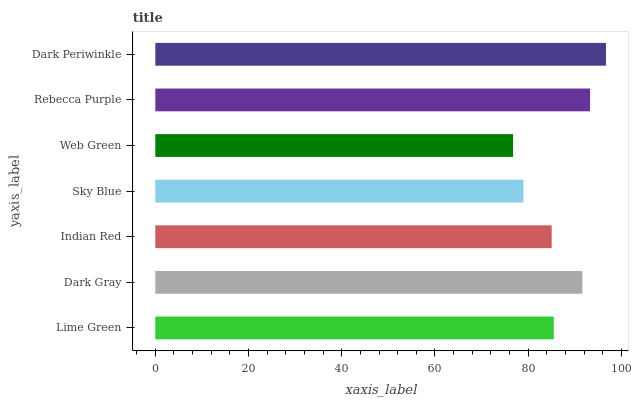Is Web Green the minimum?
Answer yes or no. Yes. Is Dark Periwinkle the maximum?
Answer yes or no. Yes. Is Dark Gray the minimum?
Answer yes or no. No. Is Dark Gray the maximum?
Answer yes or no. No. Is Dark Gray greater than Lime Green?
Answer yes or no. Yes. Is Lime Green less than Dark Gray?
Answer yes or no. Yes. Is Lime Green greater than Dark Gray?
Answer yes or no. No. Is Dark Gray less than Lime Green?
Answer yes or no. No. Is Lime Green the high median?
Answer yes or no. Yes. Is Lime Green the low median?
Answer yes or no. Yes. Is Dark Periwinkle the high median?
Answer yes or no. No. Is Indian Red the low median?
Answer yes or no. No. 